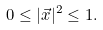Convert formula to latex. <formula><loc_0><loc_0><loc_500><loc_500>0 \leq | \vec { x } | ^ { 2 } \leq 1 .</formula> 